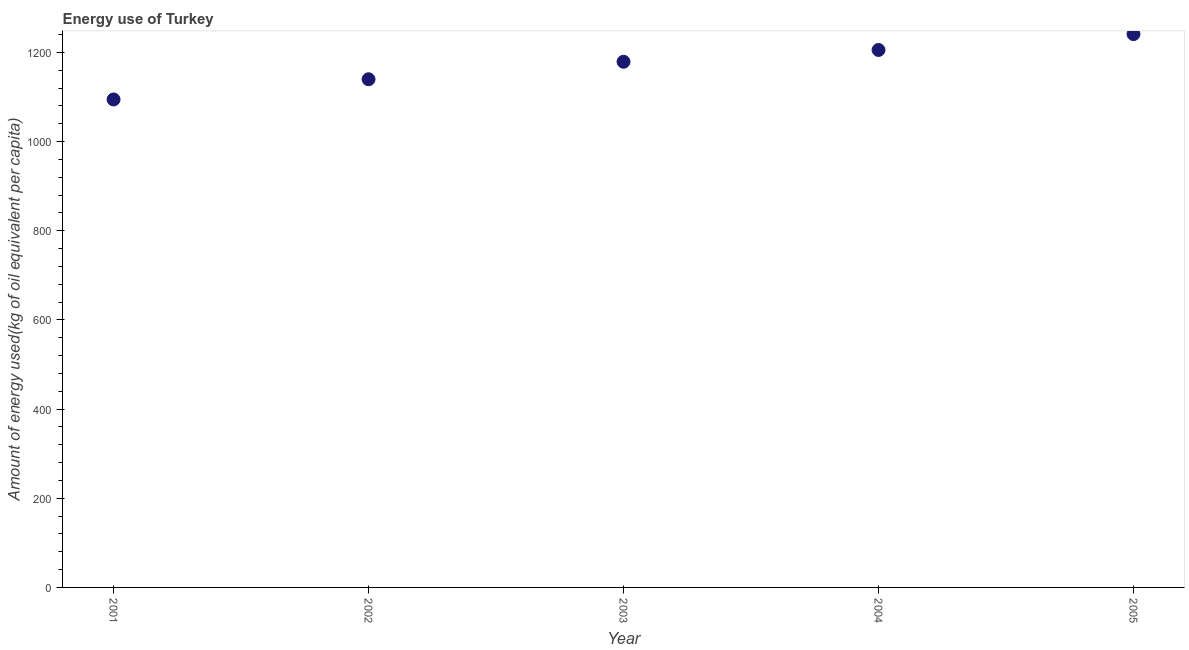What is the amount of energy used in 2001?
Offer a very short reply. 1094.35. Across all years, what is the maximum amount of energy used?
Your response must be concise. 1240.95. Across all years, what is the minimum amount of energy used?
Your answer should be compact. 1094.35. In which year was the amount of energy used maximum?
Offer a terse response. 2005. In which year was the amount of energy used minimum?
Give a very brief answer. 2001. What is the sum of the amount of energy used?
Offer a terse response. 5859.23. What is the difference between the amount of energy used in 2001 and 2003?
Keep it short and to the point. -84.55. What is the average amount of energy used per year?
Offer a very short reply. 1171.85. What is the median amount of energy used?
Ensure brevity in your answer.  1178.9. In how many years, is the amount of energy used greater than 120 kg?
Your answer should be very brief. 5. Do a majority of the years between 2001 and 2005 (inclusive) have amount of energy used greater than 680 kg?
Provide a short and direct response. Yes. What is the ratio of the amount of energy used in 2001 to that in 2002?
Offer a very short reply. 0.96. Is the amount of energy used in 2001 less than that in 2002?
Offer a very short reply. Yes. Is the difference between the amount of energy used in 2001 and 2002 greater than the difference between any two years?
Provide a succinct answer. No. What is the difference between the highest and the second highest amount of energy used?
Give a very brief answer. 35.61. What is the difference between the highest and the lowest amount of energy used?
Your response must be concise. 146.6. Does the amount of energy used monotonically increase over the years?
Make the answer very short. Yes. How many years are there in the graph?
Give a very brief answer. 5. Are the values on the major ticks of Y-axis written in scientific E-notation?
Provide a succinct answer. No. Does the graph contain any zero values?
Make the answer very short. No. What is the title of the graph?
Keep it short and to the point. Energy use of Turkey. What is the label or title of the X-axis?
Give a very brief answer. Year. What is the label or title of the Y-axis?
Ensure brevity in your answer.  Amount of energy used(kg of oil equivalent per capita). What is the Amount of energy used(kg of oil equivalent per capita) in 2001?
Offer a very short reply. 1094.35. What is the Amount of energy used(kg of oil equivalent per capita) in 2002?
Keep it short and to the point. 1139.69. What is the Amount of energy used(kg of oil equivalent per capita) in 2003?
Your answer should be compact. 1178.9. What is the Amount of energy used(kg of oil equivalent per capita) in 2004?
Your response must be concise. 1205.34. What is the Amount of energy used(kg of oil equivalent per capita) in 2005?
Give a very brief answer. 1240.95. What is the difference between the Amount of energy used(kg of oil equivalent per capita) in 2001 and 2002?
Ensure brevity in your answer.  -45.35. What is the difference between the Amount of energy used(kg of oil equivalent per capita) in 2001 and 2003?
Offer a very short reply. -84.55. What is the difference between the Amount of energy used(kg of oil equivalent per capita) in 2001 and 2004?
Provide a short and direct response. -110.99. What is the difference between the Amount of energy used(kg of oil equivalent per capita) in 2001 and 2005?
Provide a short and direct response. -146.6. What is the difference between the Amount of energy used(kg of oil equivalent per capita) in 2002 and 2003?
Offer a very short reply. -39.21. What is the difference between the Amount of energy used(kg of oil equivalent per capita) in 2002 and 2004?
Keep it short and to the point. -65.64. What is the difference between the Amount of energy used(kg of oil equivalent per capita) in 2002 and 2005?
Your answer should be compact. -101.25. What is the difference between the Amount of energy used(kg of oil equivalent per capita) in 2003 and 2004?
Provide a succinct answer. -26.44. What is the difference between the Amount of energy used(kg of oil equivalent per capita) in 2003 and 2005?
Offer a very short reply. -62.05. What is the difference between the Amount of energy used(kg of oil equivalent per capita) in 2004 and 2005?
Your response must be concise. -35.61. What is the ratio of the Amount of energy used(kg of oil equivalent per capita) in 2001 to that in 2003?
Offer a very short reply. 0.93. What is the ratio of the Amount of energy used(kg of oil equivalent per capita) in 2001 to that in 2004?
Give a very brief answer. 0.91. What is the ratio of the Amount of energy used(kg of oil equivalent per capita) in 2001 to that in 2005?
Your answer should be compact. 0.88. What is the ratio of the Amount of energy used(kg of oil equivalent per capita) in 2002 to that in 2004?
Provide a succinct answer. 0.95. What is the ratio of the Amount of energy used(kg of oil equivalent per capita) in 2002 to that in 2005?
Make the answer very short. 0.92. What is the ratio of the Amount of energy used(kg of oil equivalent per capita) in 2003 to that in 2004?
Ensure brevity in your answer.  0.98. What is the ratio of the Amount of energy used(kg of oil equivalent per capita) in 2003 to that in 2005?
Give a very brief answer. 0.95. 